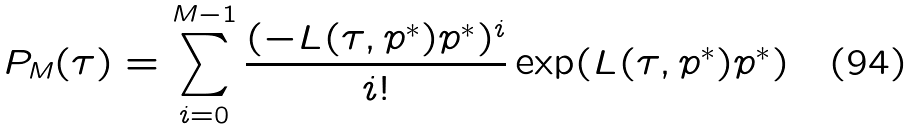Convert formula to latex. <formula><loc_0><loc_0><loc_500><loc_500>P _ { M } ( \tau ) = \sum _ { i = 0 } ^ { M - 1 } \frac { ( - L ( \tau , p ^ { * } ) p ^ { * } ) ^ { i } } { i ! } \exp ( L ( \tau , p ^ { * } ) p ^ { * } )</formula> 